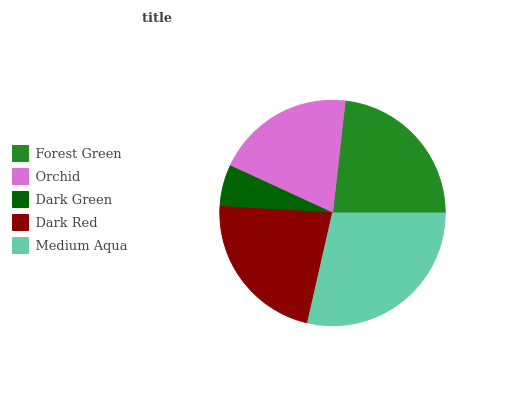Is Dark Green the minimum?
Answer yes or no. Yes. Is Medium Aqua the maximum?
Answer yes or no. Yes. Is Orchid the minimum?
Answer yes or no. No. Is Orchid the maximum?
Answer yes or no. No. Is Forest Green greater than Orchid?
Answer yes or no. Yes. Is Orchid less than Forest Green?
Answer yes or no. Yes. Is Orchid greater than Forest Green?
Answer yes or no. No. Is Forest Green less than Orchid?
Answer yes or no. No. Is Dark Red the high median?
Answer yes or no. Yes. Is Dark Red the low median?
Answer yes or no. Yes. Is Forest Green the high median?
Answer yes or no. No. Is Orchid the low median?
Answer yes or no. No. 